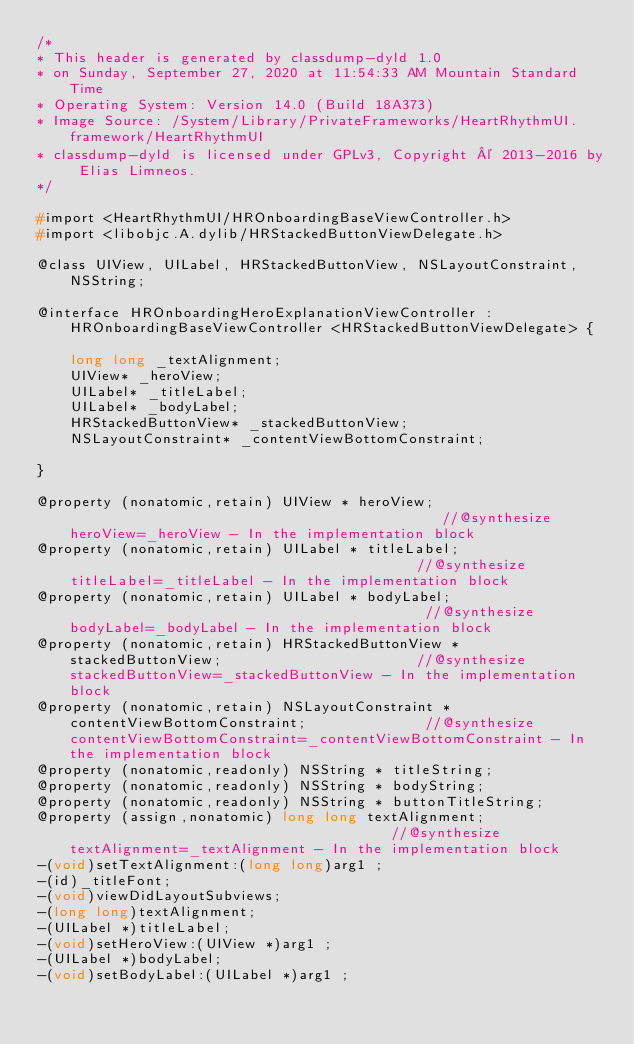Convert code to text. <code><loc_0><loc_0><loc_500><loc_500><_C_>/*
* This header is generated by classdump-dyld 1.0
* on Sunday, September 27, 2020 at 11:54:33 AM Mountain Standard Time
* Operating System: Version 14.0 (Build 18A373)
* Image Source: /System/Library/PrivateFrameworks/HeartRhythmUI.framework/HeartRhythmUI
* classdump-dyld is licensed under GPLv3, Copyright © 2013-2016 by Elias Limneos.
*/

#import <HeartRhythmUI/HROnboardingBaseViewController.h>
#import <libobjc.A.dylib/HRStackedButtonViewDelegate.h>

@class UIView, UILabel, HRStackedButtonView, NSLayoutConstraint, NSString;

@interface HROnboardingHeroExplanationViewController : HROnboardingBaseViewController <HRStackedButtonViewDelegate> {

	long long _textAlignment;
	UIView* _heroView;
	UILabel* _titleLabel;
	UILabel* _bodyLabel;
	HRStackedButtonView* _stackedButtonView;
	NSLayoutConstraint* _contentViewBottomConstraint;

}

@property (nonatomic,retain) UIView * heroView;                                             //@synthesize heroView=_heroView - In the implementation block
@property (nonatomic,retain) UILabel * titleLabel;                                          //@synthesize titleLabel=_titleLabel - In the implementation block
@property (nonatomic,retain) UILabel * bodyLabel;                                           //@synthesize bodyLabel=_bodyLabel - In the implementation block
@property (nonatomic,retain) HRStackedButtonView * stackedButtonView;                       //@synthesize stackedButtonView=_stackedButtonView - In the implementation block
@property (nonatomic,retain) NSLayoutConstraint * contentViewBottomConstraint;              //@synthesize contentViewBottomConstraint=_contentViewBottomConstraint - In the implementation block
@property (nonatomic,readonly) NSString * titleString; 
@property (nonatomic,readonly) NSString * bodyString; 
@property (nonatomic,readonly) NSString * buttonTitleString; 
@property (assign,nonatomic) long long textAlignment;                                       //@synthesize textAlignment=_textAlignment - In the implementation block
-(void)setTextAlignment:(long long)arg1 ;
-(id)_titleFont;
-(void)viewDidLayoutSubviews;
-(long long)textAlignment;
-(UILabel *)titleLabel;
-(void)setHeroView:(UIView *)arg1 ;
-(UILabel *)bodyLabel;
-(void)setBodyLabel:(UILabel *)arg1 ;</code> 